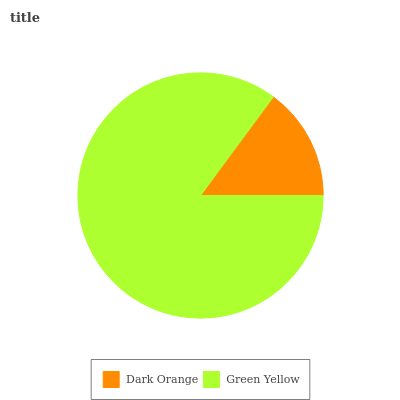Is Dark Orange the minimum?
Answer yes or no. Yes. Is Green Yellow the maximum?
Answer yes or no. Yes. Is Green Yellow the minimum?
Answer yes or no. No. Is Green Yellow greater than Dark Orange?
Answer yes or no. Yes. Is Dark Orange less than Green Yellow?
Answer yes or no. Yes. Is Dark Orange greater than Green Yellow?
Answer yes or no. No. Is Green Yellow less than Dark Orange?
Answer yes or no. No. Is Green Yellow the high median?
Answer yes or no. Yes. Is Dark Orange the low median?
Answer yes or no. Yes. Is Dark Orange the high median?
Answer yes or no. No. Is Green Yellow the low median?
Answer yes or no. No. 